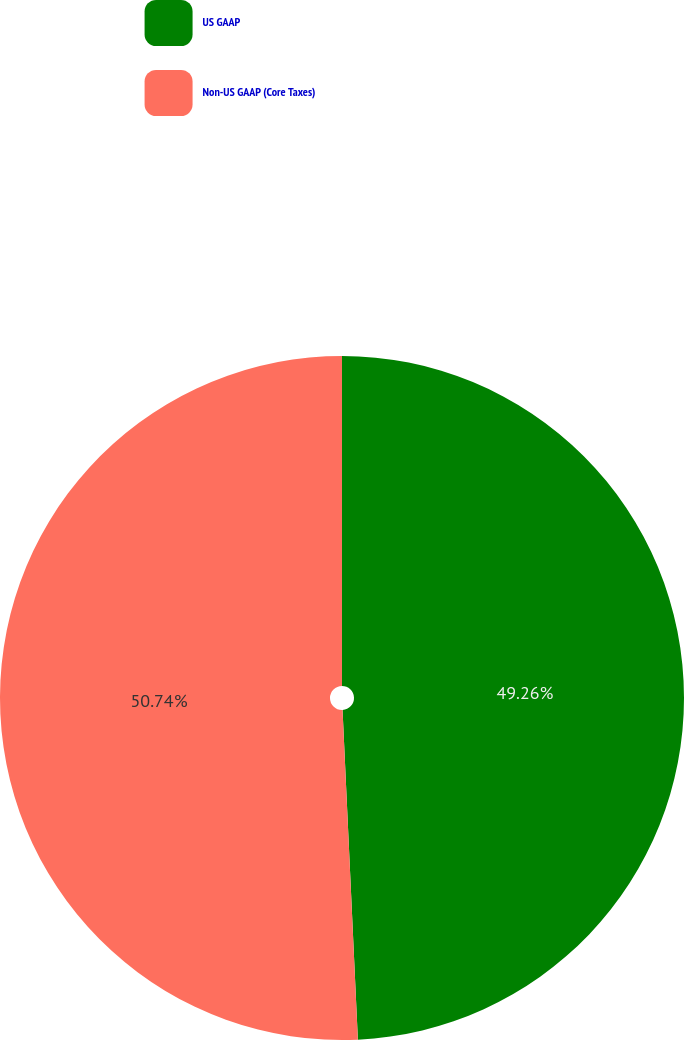<chart> <loc_0><loc_0><loc_500><loc_500><pie_chart><fcel>US GAAP<fcel>Non-US GAAP (Core Taxes)<nl><fcel>49.26%<fcel>50.74%<nl></chart> 